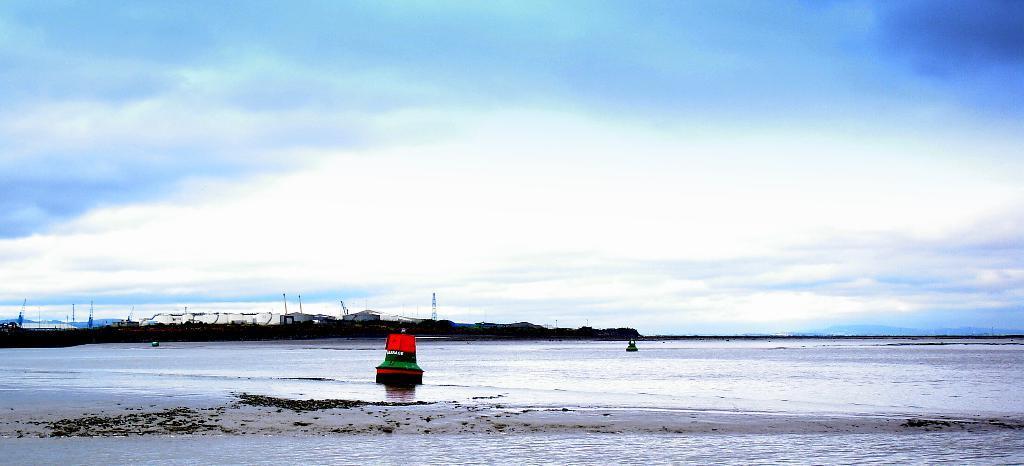Can you describe this image briefly? In this picture I can observe an ocean. There are two boats floating on the water. In the background I can observe some clouds in the sky. 